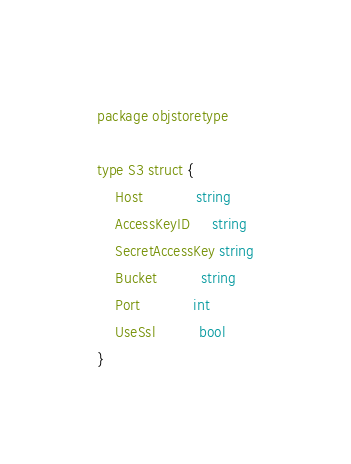Convert code to text. <code><loc_0><loc_0><loc_500><loc_500><_Go_>package objstoretype

type S3 struct {
	Host            string
	AccessKeyID     string
	SecretAccessKey string
	Bucket          string
	Port            int
	UseSsl          bool
}
</code> 